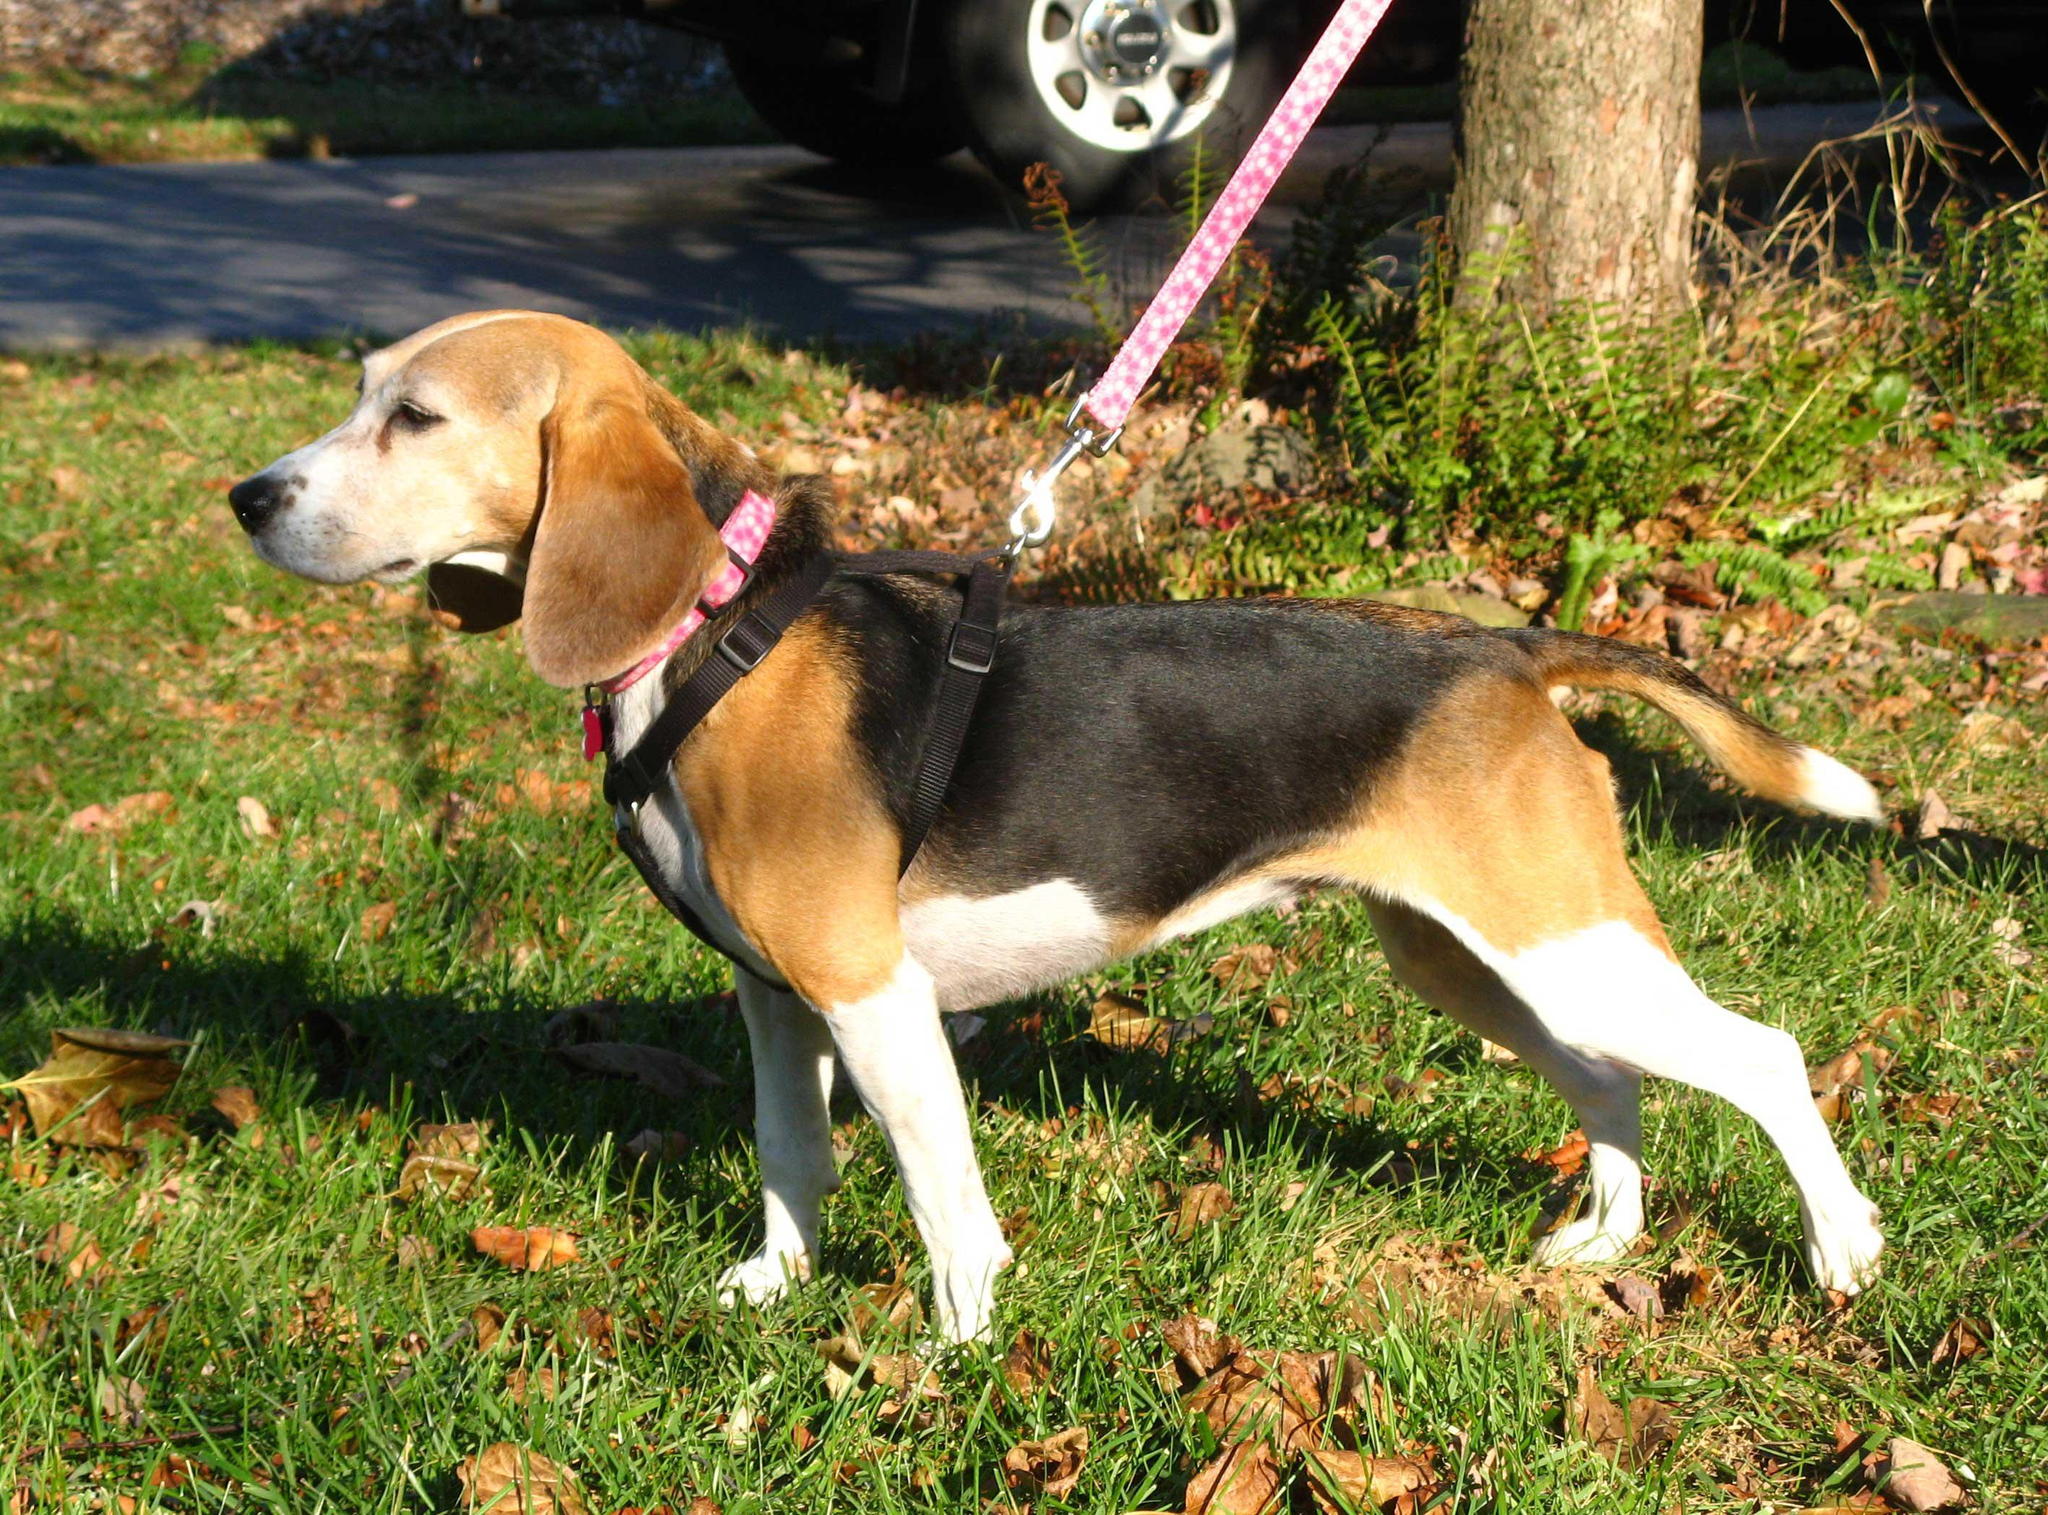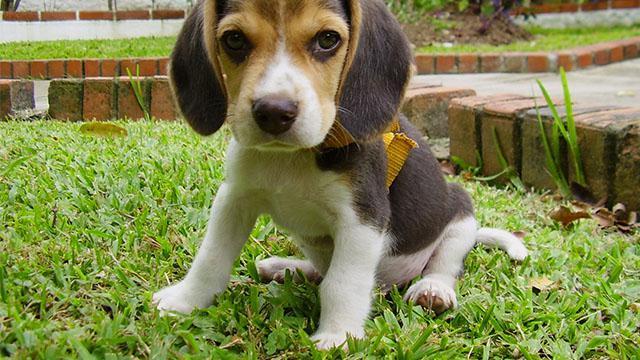The first image is the image on the left, the second image is the image on the right. For the images shown, is this caption "In the right image, the beagle wears a leash." true? Answer yes or no. No. 